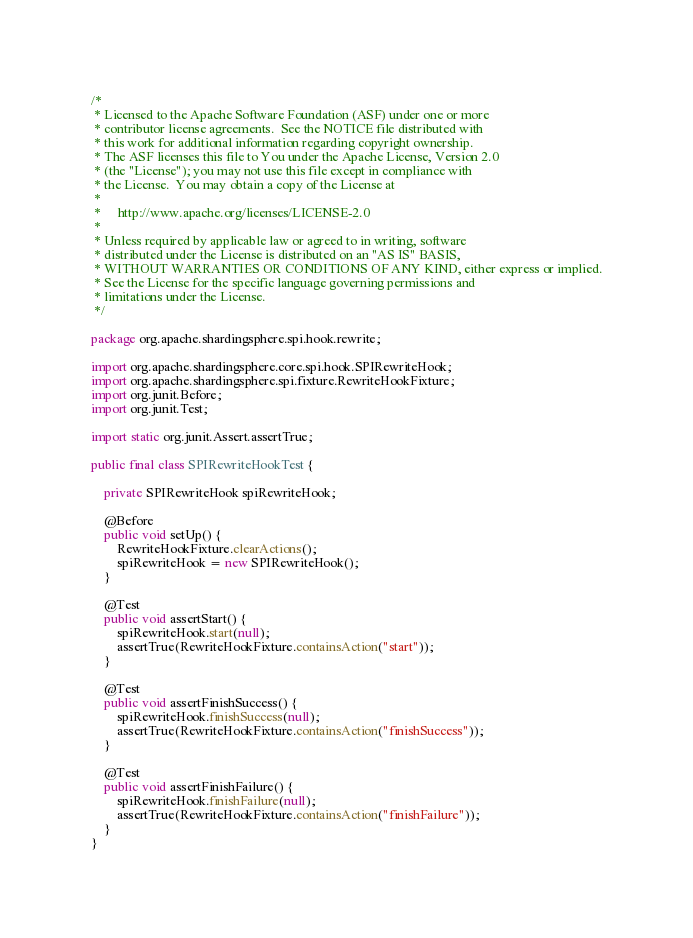Convert code to text. <code><loc_0><loc_0><loc_500><loc_500><_Java_>/*
 * Licensed to the Apache Software Foundation (ASF) under one or more
 * contributor license agreements.  See the NOTICE file distributed with
 * this work for additional information regarding copyright ownership.
 * The ASF licenses this file to You under the Apache License, Version 2.0
 * (the "License"); you may not use this file except in compliance with
 * the License.  You may obtain a copy of the License at
 *
 *     http://www.apache.org/licenses/LICENSE-2.0
 *
 * Unless required by applicable law or agreed to in writing, software
 * distributed under the License is distributed on an "AS IS" BASIS,
 * WITHOUT WARRANTIES OR CONDITIONS OF ANY KIND, either express or implied.
 * See the License for the specific language governing permissions and
 * limitations under the License.
 */

package org.apache.shardingsphere.spi.hook.rewrite;

import org.apache.shardingsphere.core.spi.hook.SPIRewriteHook;
import org.apache.shardingsphere.spi.fixture.RewriteHookFixture;
import org.junit.Before;
import org.junit.Test;

import static org.junit.Assert.assertTrue;

public final class SPIRewriteHookTest {
    
    private SPIRewriteHook spiRewriteHook;
    
    @Before
    public void setUp() {
        RewriteHookFixture.clearActions();
        spiRewriteHook = new SPIRewriteHook();
    }
    
    @Test
    public void assertStart() {
        spiRewriteHook.start(null);
        assertTrue(RewriteHookFixture.containsAction("start"));
    }
    
    @Test
    public void assertFinishSuccess() {
        spiRewriteHook.finishSuccess(null);
        assertTrue(RewriteHookFixture.containsAction("finishSuccess"));
    }
    
    @Test
    public void assertFinishFailure() {
        spiRewriteHook.finishFailure(null);
        assertTrue(RewriteHookFixture.containsAction("finishFailure"));
    }
}
</code> 